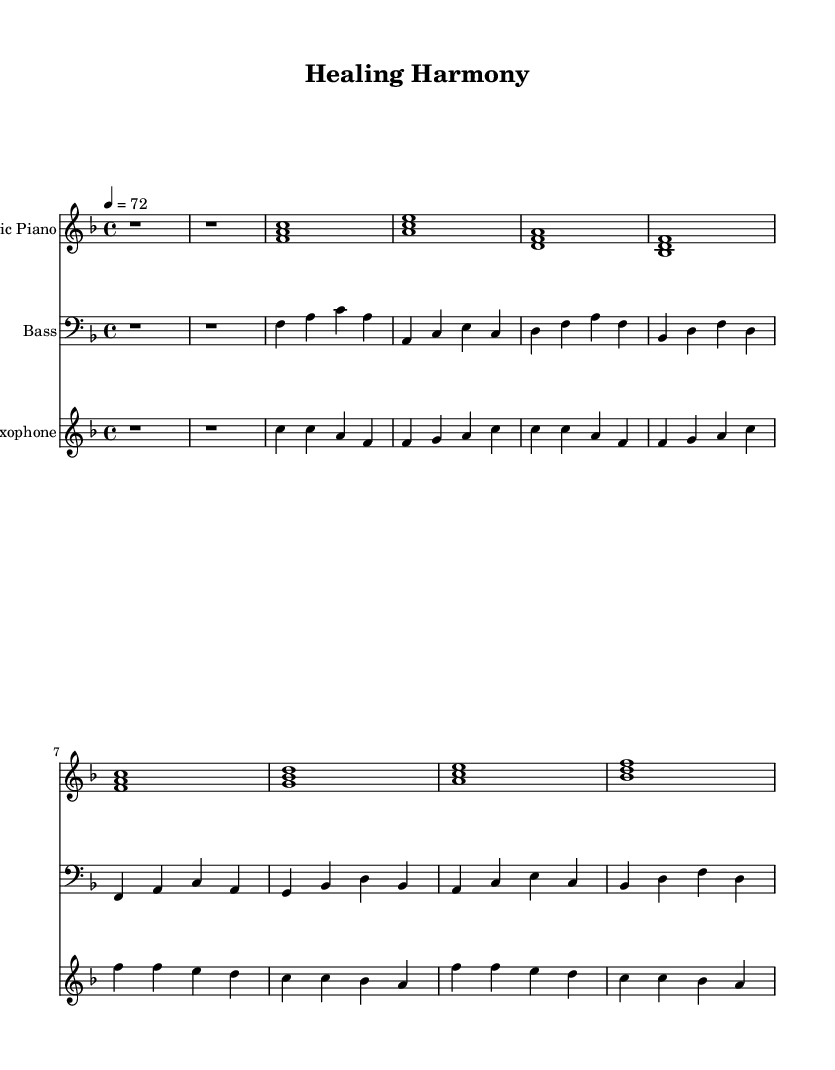What is the key signature of this music? The key signature is F major, which has one flat (B flat). This is indicated at the beginning of the staff with the B flat symbol.
Answer: F major What is the time signature of this music? The time signature is 4/4, which means there are four beats in each measure and the quarter note gets one beat. This is indicated at the beginning of the score.
Answer: 4/4 What is the tempo marking for this piece? The tempo marking is 72 beats per minute, which is indicated as "4 = 72" at the start of the music.
Answer: 72 How many distinct sections can be identified in this piece? The score shows two clear sections labeled as "Verse" and "Chorus". There is an Intro, followed by the Verse section, and then the Chorus section appears next.
Answer: Three What is the last note in the saxophone melody? The last note in the saxophone melody is A, which is indicated in the final measure of the saxophone staff.
Answer: A What instruments are used in this piece? The instruments listed in the score are Electric Piano, Bass, and Saxophone. These can be seen at the beginning of each staff in the score layout.
Answer: Electric Piano, Bass, Saxophone What genre does this piece exemplify? The overall style and feel of the piece, along with its instrumentation, indicate that it falls within the Soul genre, which is characterized by its smooth grooves and emphasis on relaxation and groove.
Answer: Soul 